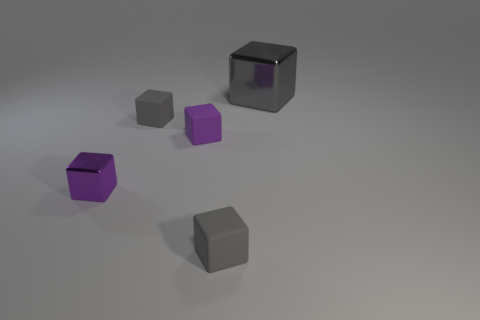Add 5 purple rubber blocks. How many objects exist? 10 Subtract 0 red cubes. How many objects are left? 5 How many gray blocks must be subtracted to get 1 gray blocks? 2 Subtract 1 cubes. How many cubes are left? 4 Subtract all green blocks. Subtract all green balls. How many blocks are left? 5 Subtract all cyan cylinders. How many blue blocks are left? 0 Subtract all gray shiny blocks. Subtract all tiny rubber cubes. How many objects are left? 1 Add 1 small gray matte things. How many small gray matte things are left? 3 Add 5 matte cubes. How many matte cubes exist? 8 Subtract all purple blocks. How many blocks are left? 3 